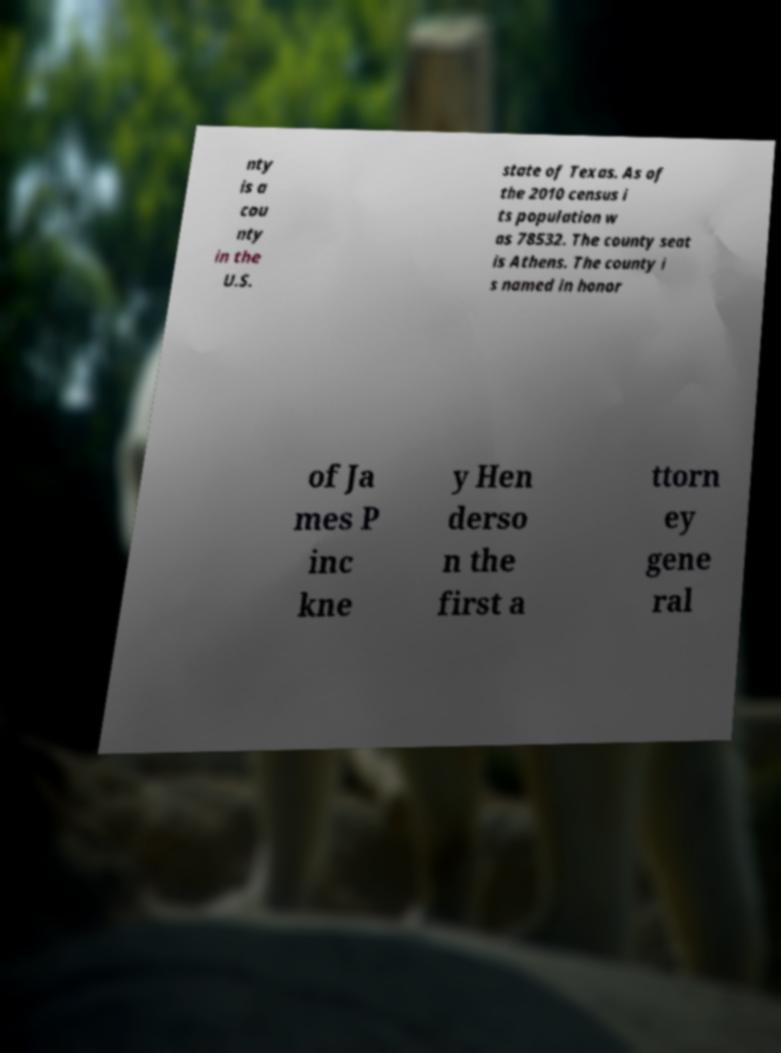There's text embedded in this image that I need extracted. Can you transcribe it verbatim? nty is a cou nty in the U.S. state of Texas. As of the 2010 census i ts population w as 78532. The county seat is Athens. The county i s named in honor of Ja mes P inc kne y Hen derso n the first a ttorn ey gene ral 